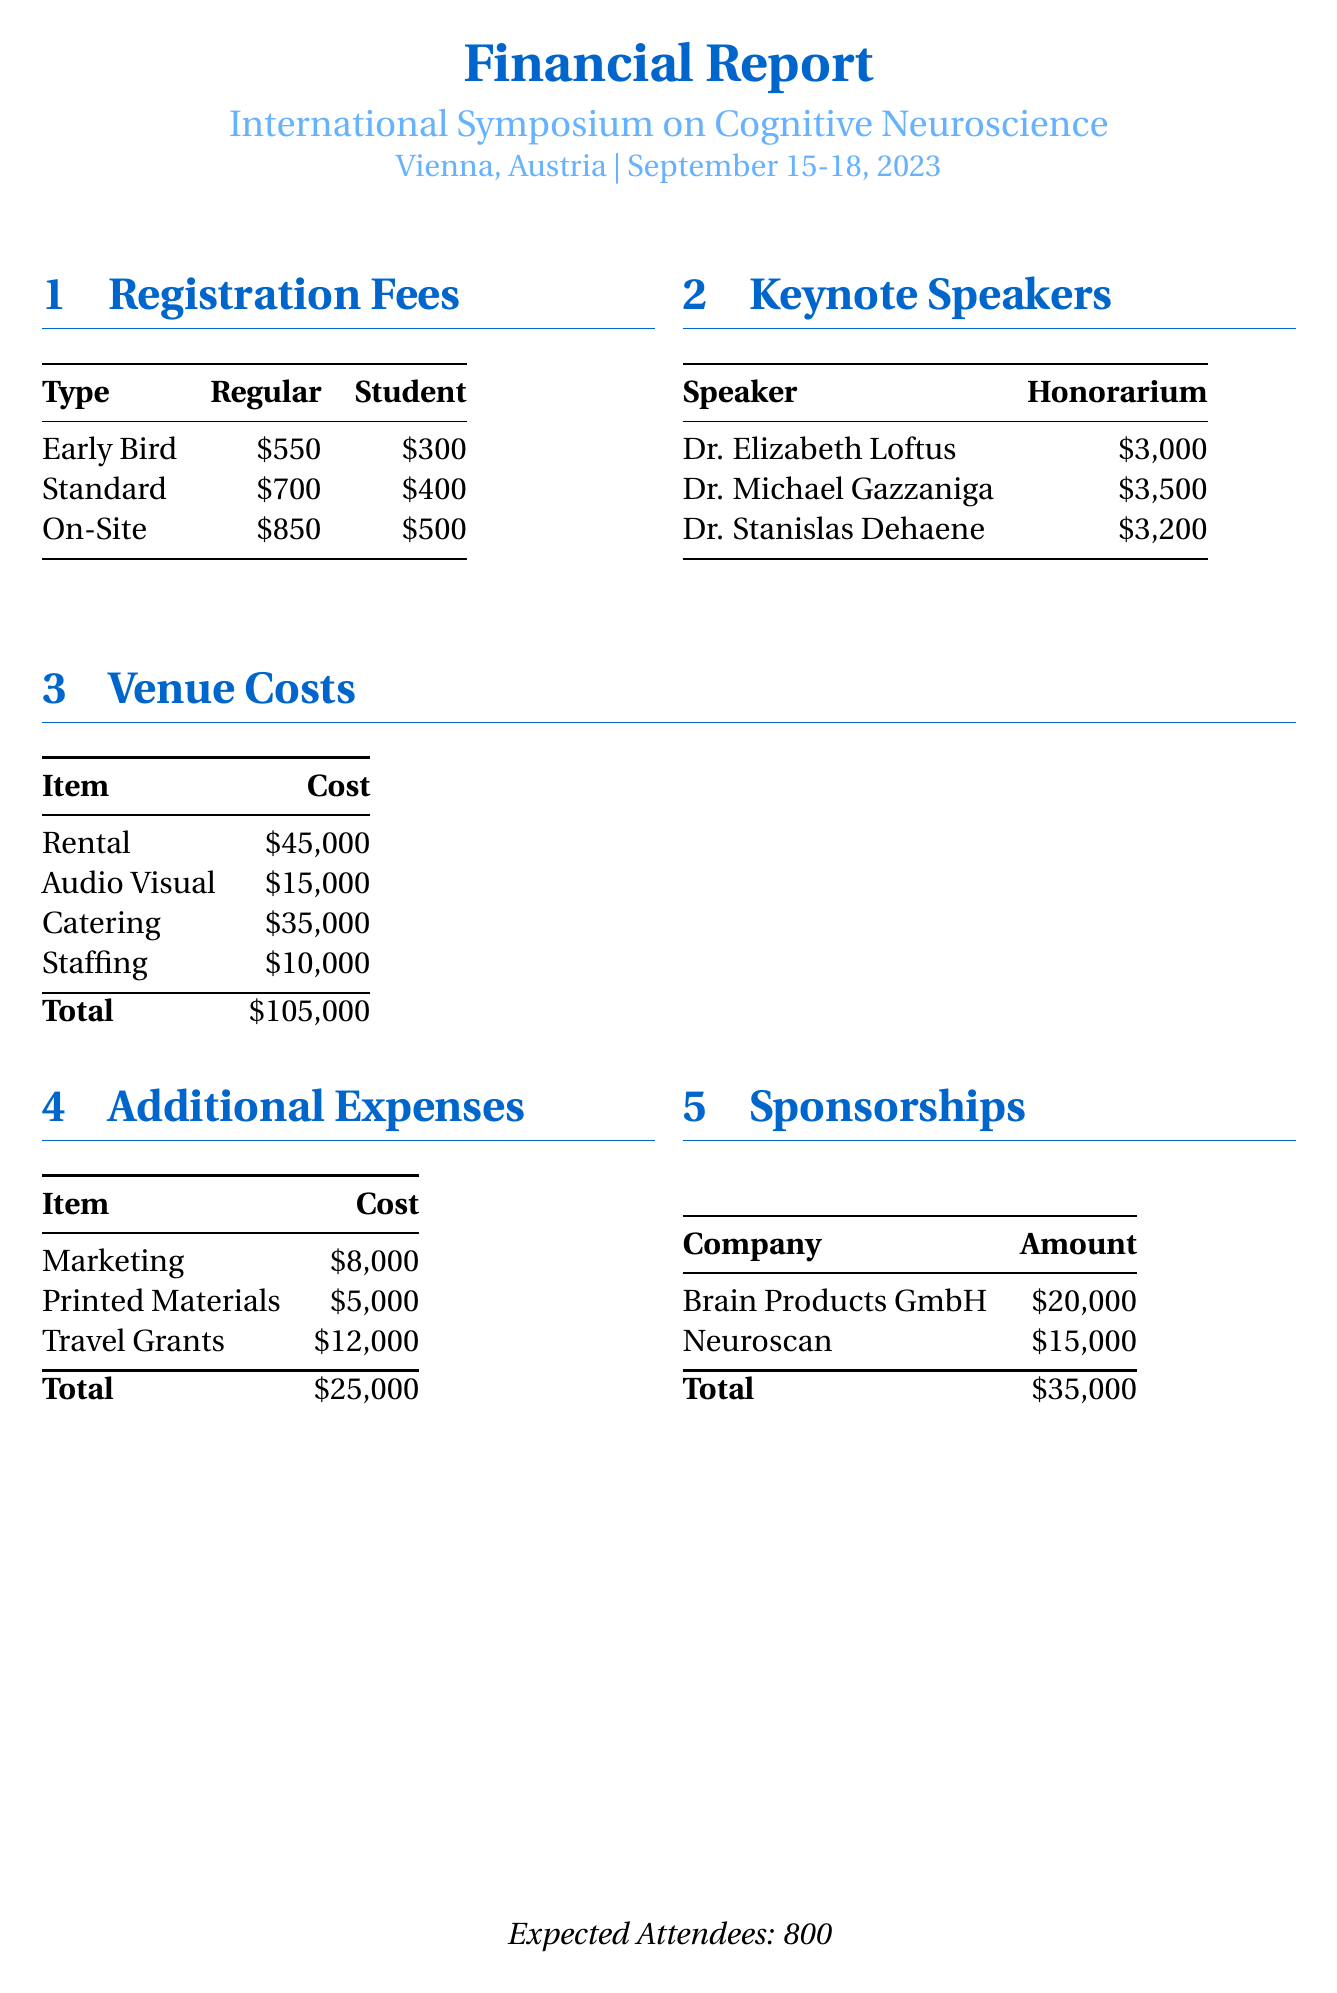What is the location of the conference? The location of the conference is specified in the document as Vienna, Austria.
Answer: Vienna, Austria What is the early bird regular registration fee? The document lists the early bird regular registration fee as $550.
Answer: $550 Who is the speaker with the highest honorarium? The honorarium amounts indicate that Dr. Michael Gazzaniga has the highest honorarium of $3500.
Answer: Dr. Michael Gazzaniga What is the total venue cost? The total venue cost is calculated by summing all individual venue costs mentioned in the document, resulting in $105,000.
Answer: $105,000 How much was allocated for travel grants? The document specifies that $12,000 was allocated for travel grants under additional expenses.
Answer: $12,000 What is the total amount from sponsorships? The document states that the total amount received from sponsorships is $35,000.
Answer: $35,000 How many expected attendees are there? The document clearly states that the expected number of attendees is 800.
Answer: 800 What is the cost of catering? According to the venue costs section of the document, catering costs $35,000.
Answer: $35,000 What type of expenses does the document include? The document includes registration fees, venue costs, speaker honorariums, and additional expenses as types of expenses.
Answer: Registration fees, venue costs, speaker honorariums, additional expenses 